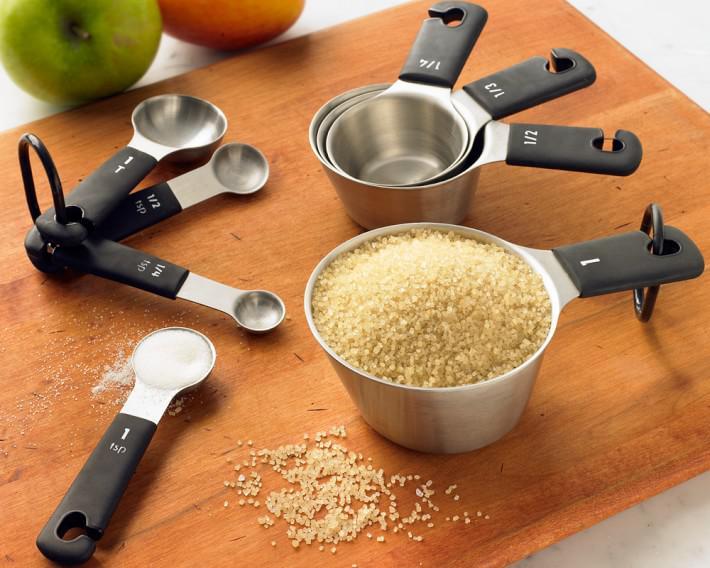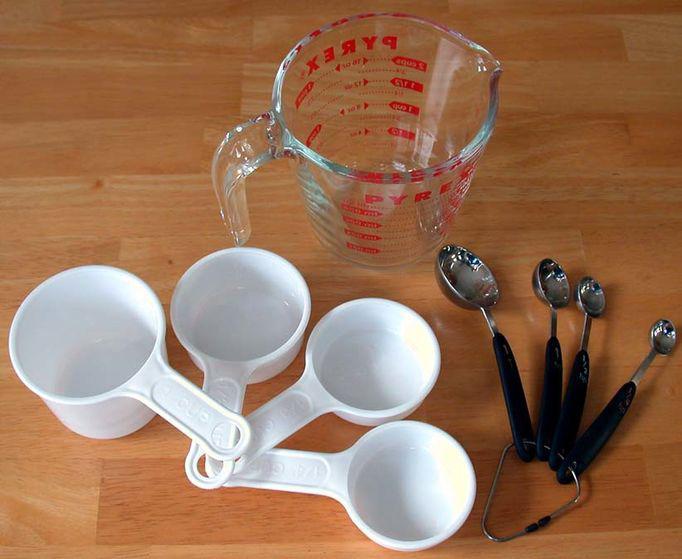The first image is the image on the left, the second image is the image on the right. Evaluate the accuracy of this statement regarding the images: "There is at least clear measuring cup in one of the images.". Is it true? Answer yes or no. Yes. 